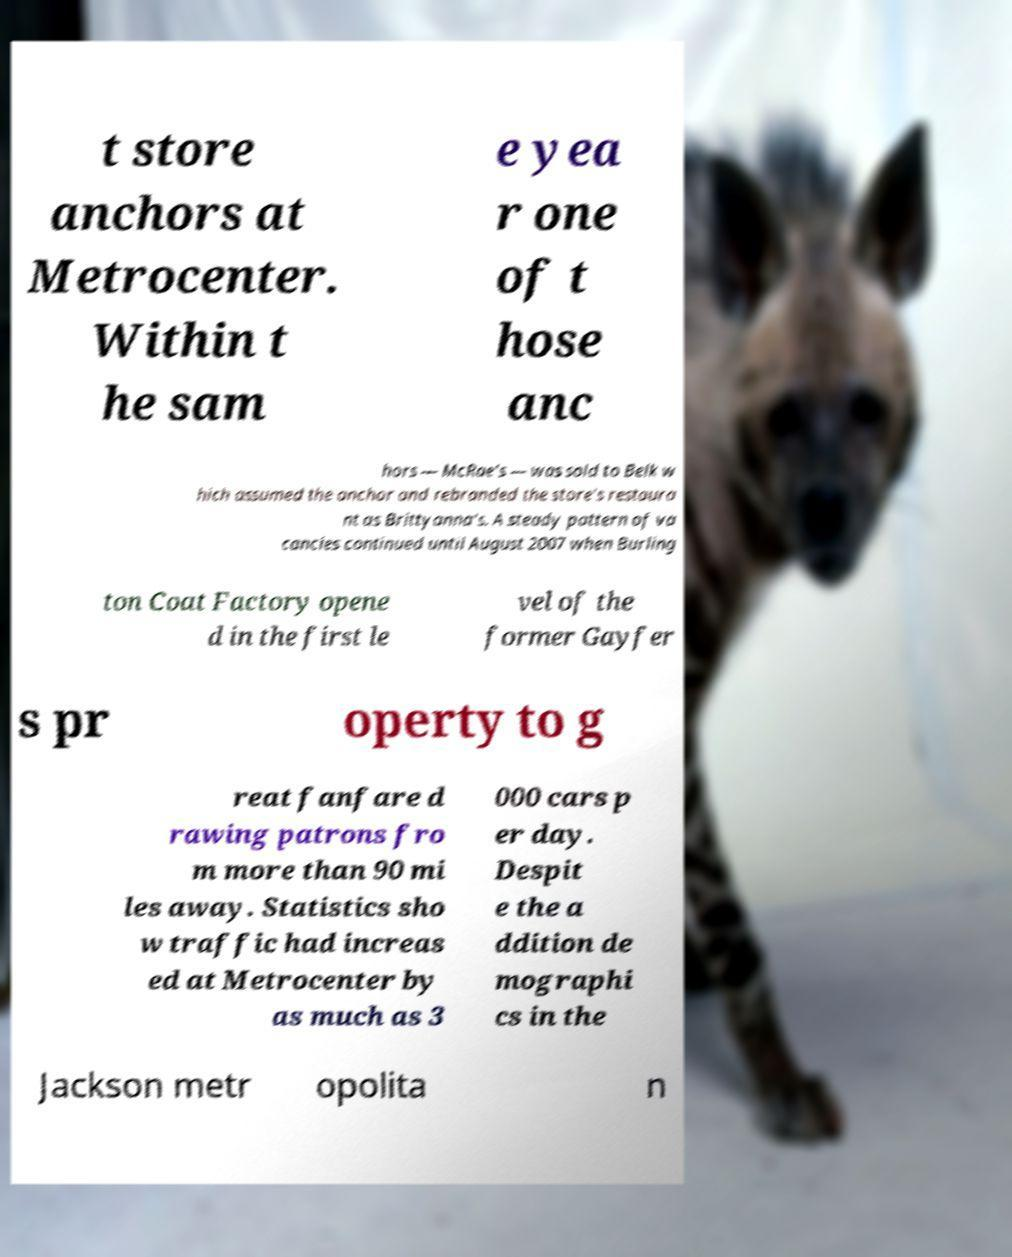There's text embedded in this image that I need extracted. Can you transcribe it verbatim? t store anchors at Metrocenter. Within t he sam e yea r one of t hose anc hors — McRae's — was sold to Belk w hich assumed the anchor and rebranded the store's restaura nt as Brittyanna's. A steady pattern of va cancies continued until August 2007 when Burling ton Coat Factory opene d in the first le vel of the former Gayfer s pr operty to g reat fanfare d rawing patrons fro m more than 90 mi les away. Statistics sho w traffic had increas ed at Metrocenter by as much as 3 000 cars p er day. Despit e the a ddition de mographi cs in the Jackson metr opolita n 